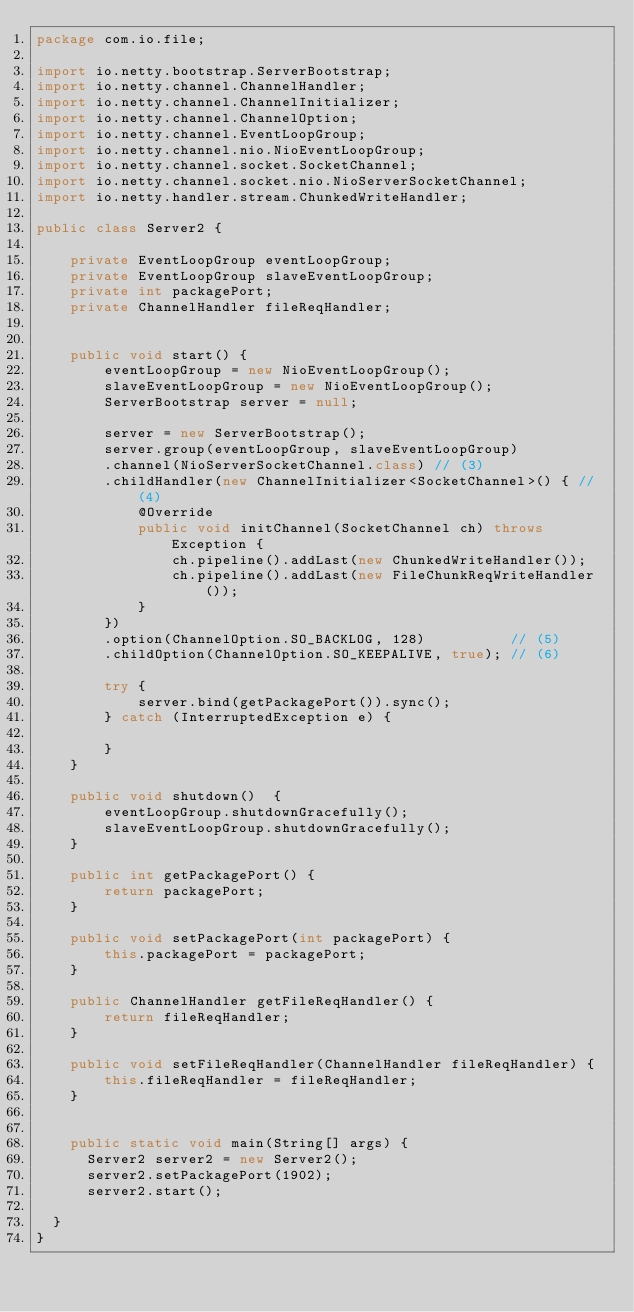<code> <loc_0><loc_0><loc_500><loc_500><_Java_>package com.io.file;

import io.netty.bootstrap.ServerBootstrap;
import io.netty.channel.ChannelHandler;
import io.netty.channel.ChannelInitializer;
import io.netty.channel.ChannelOption;
import io.netty.channel.EventLoopGroup;
import io.netty.channel.nio.NioEventLoopGroup;
import io.netty.channel.socket.SocketChannel;
import io.netty.channel.socket.nio.NioServerSocketChannel;
import io.netty.handler.stream.ChunkedWriteHandler;

public class Server2 {

    private EventLoopGroup eventLoopGroup;
    private EventLoopGroup slaveEventLoopGroup;
    private int packagePort;
    private ChannelHandler fileReqHandler;


    public void start() {
        eventLoopGroup = new NioEventLoopGroup();
        slaveEventLoopGroup = new NioEventLoopGroup();
        ServerBootstrap server = null;

        server = new ServerBootstrap();
        server.group(eventLoopGroup, slaveEventLoopGroup)
        .channel(NioServerSocketChannel.class) // (3)
        .childHandler(new ChannelInitializer<SocketChannel>() { // (4)
            @Override
            public void initChannel(SocketChannel ch) throws Exception {
                ch.pipeline().addLast(new ChunkedWriteHandler());
                ch.pipeline().addLast(new FileChunkReqWriteHandler());
            }
        })
        .option(ChannelOption.SO_BACKLOG, 128)          // (5)
        .childOption(ChannelOption.SO_KEEPALIVE, true); // (6)

        try {
            server.bind(getPackagePort()).sync();
        } catch (InterruptedException e) {
           
        }        
    }

    public void shutdown()  {
        eventLoopGroup.shutdownGracefully();
        slaveEventLoopGroup.shutdownGracefully();        
    }

    public int getPackagePort() {
        return packagePort;
    }

    public void setPackagePort(int packagePort) {
        this.packagePort = packagePort;
    }

    public ChannelHandler getFileReqHandler() {
        return fileReqHandler;
    }

    public void setFileReqHandler(ChannelHandler fileReqHandler) {
        this.fileReqHandler = fileReqHandler;
    }

    
    public static void main(String[] args) {
    	Server2 server2 = new Server2();
    	server2.setPackagePort(1902);
    	server2.start();
    	
	}
}
</code> 